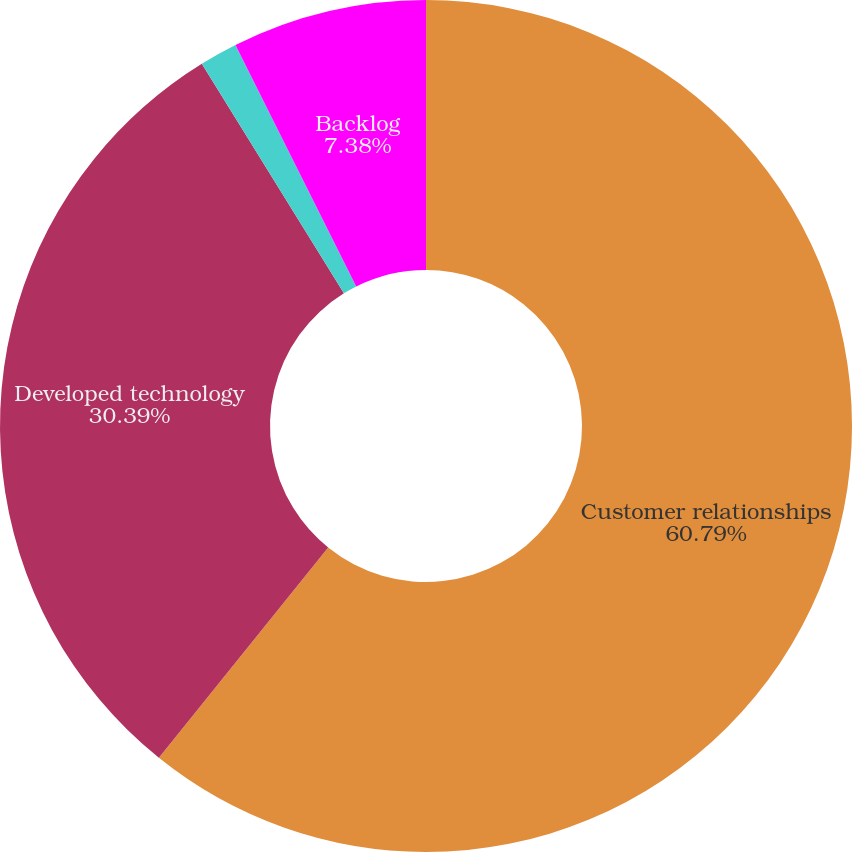Convert chart. <chart><loc_0><loc_0><loc_500><loc_500><pie_chart><fcel>Customer relationships<fcel>Developed technology<fcel>Trade names<fcel>Backlog<nl><fcel>60.78%<fcel>30.39%<fcel>1.44%<fcel>7.38%<nl></chart> 